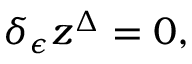Convert formula to latex. <formula><loc_0><loc_0><loc_500><loc_500>\delta _ { \epsilon } z ^ { \Delta } = 0 ,</formula> 